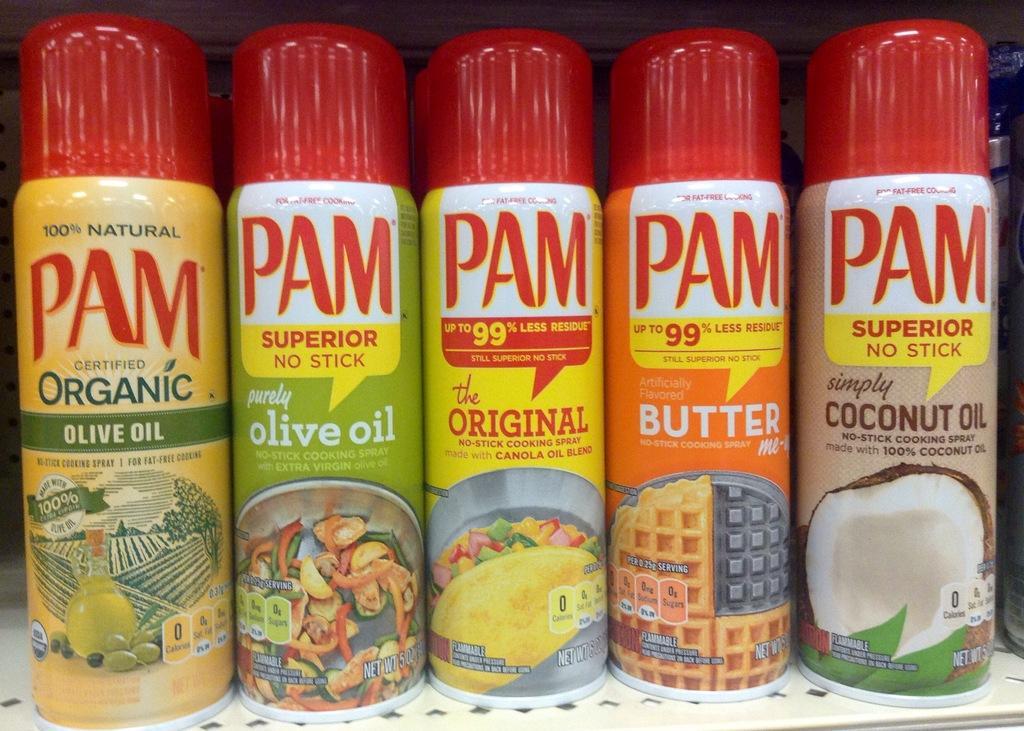Describe this image in one or two sentences. In this image I can see five spray bottles and on these bottles I can see something is written. 